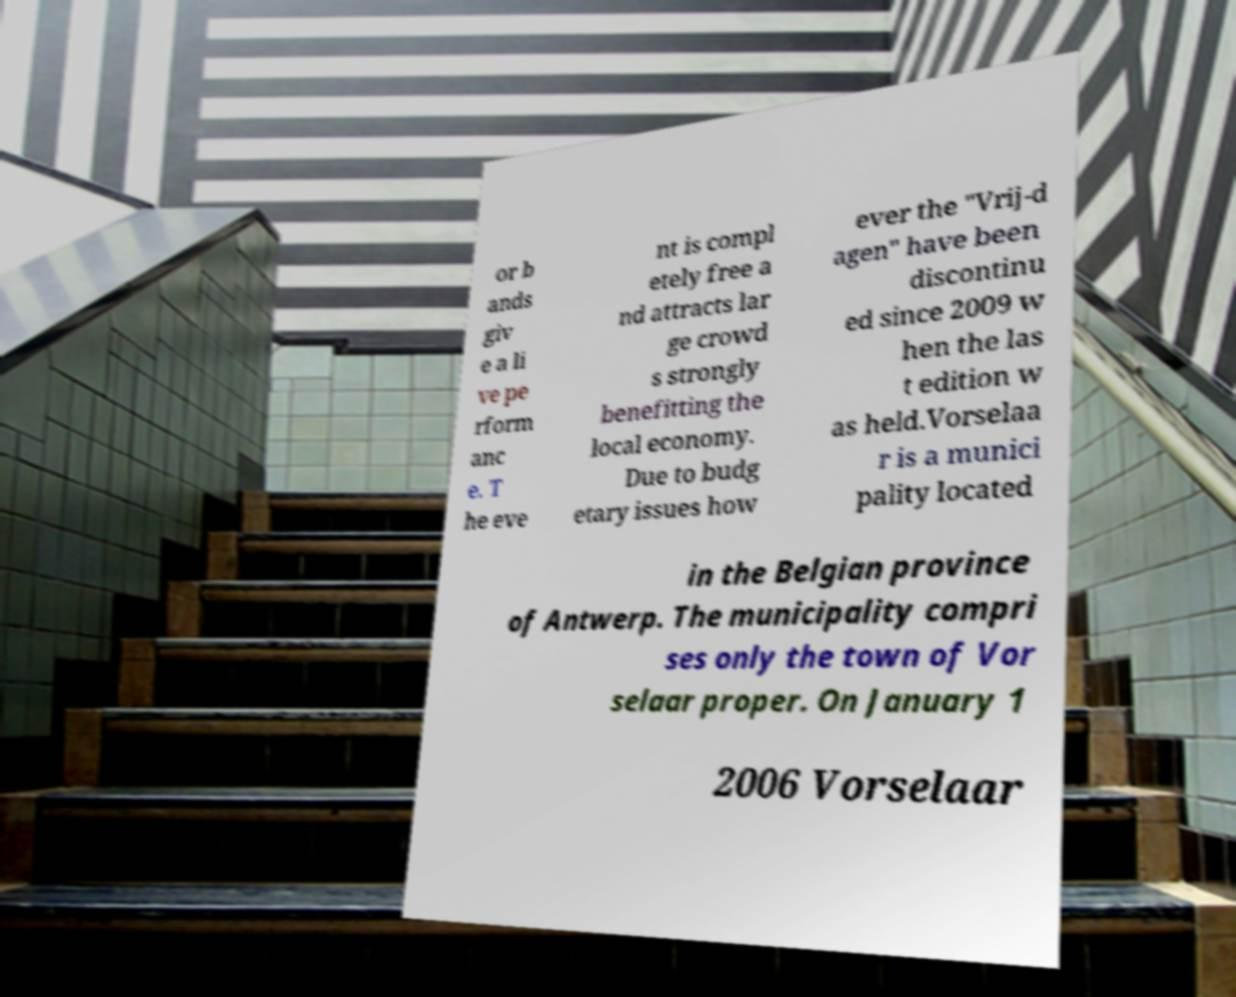Can you read and provide the text displayed in the image?This photo seems to have some interesting text. Can you extract and type it out for me? or b ands giv e a li ve pe rform anc e. T he eve nt is compl etely free a nd attracts lar ge crowd s strongly benefitting the local economy. Due to budg etary issues how ever the "Vrij-d agen" have been discontinu ed since 2009 w hen the las t edition w as held.Vorselaa r is a munici pality located in the Belgian province of Antwerp. The municipality compri ses only the town of Vor selaar proper. On January 1 2006 Vorselaar 